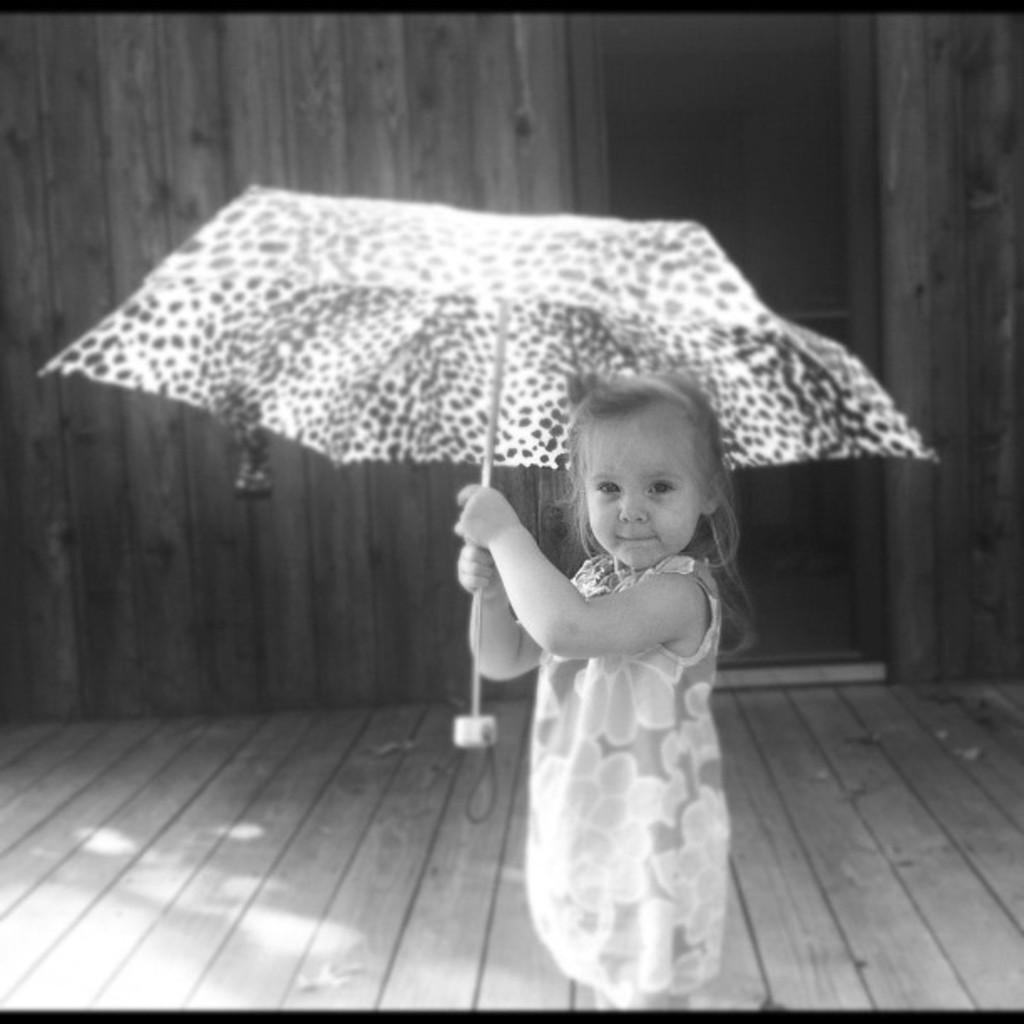What is the color scheme of the image? The image is in black and white. Who is present in the image? There is a girl in the image. What is the girl doing in the image? The girl is standing in the image. What object is the girl holding in her hand? The girl is holding an umbrella in her hand. What structures can be seen in the background of the image? There is a door and a wall in the image. What brand of toothpaste is the girl using in the image? There is no toothpaste present in the image, as the girl is holding an umbrella. What type of trousers is the girl wearing in the image? The image is in black and white, so it is difficult to determine the type of trousers the girl is wearing. Additionally, the focus of the image is on the girl holding an umbrella, not her clothing. 